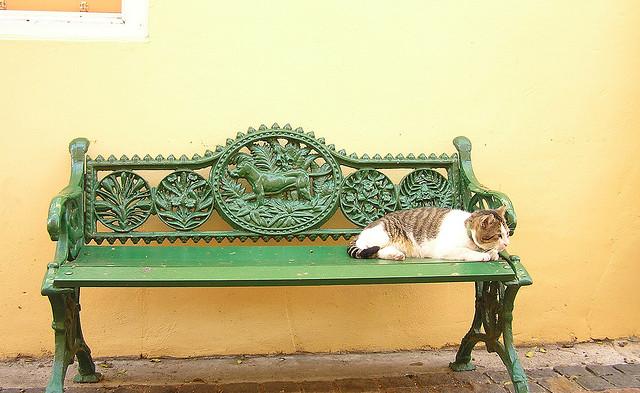What color is the bench?
Answer briefly. Green. What is on the bench?
Quick response, please. Cat. What is the cat laying on?
Write a very short answer. Bench. What is in front of the wall?
Quick response, please. Bench. 